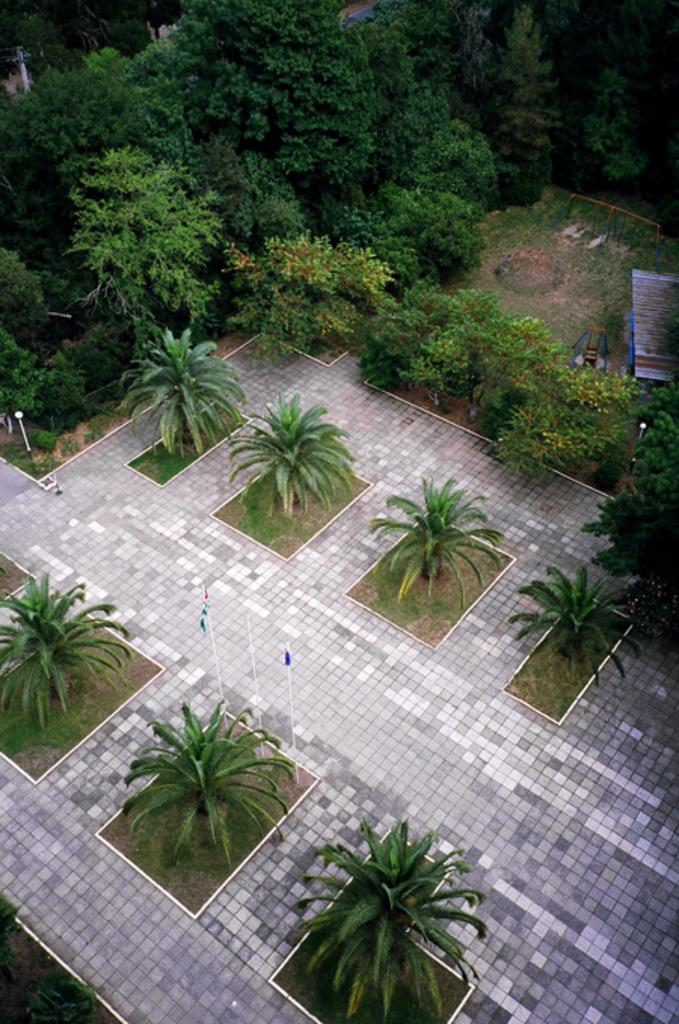What type of surface is visible in the image? There is flooring in the image. What natural elements can be seen in the image? There are trees in the image. What man-made objects are present in the image? There are flags in the image. Where is the bench located in the image? The bench is on the right side of the image. Reasoning: Let' background elements, such as the trees, and the man-made objects, like the flags. We also mention the bench and its location to provide a sense of the overall setting. Each question is designed to elicit a specific detail about the image that is known from the provided facts. Absurd Question/Answer: What type of fish can be seen swimming near the queen in the image? There is no queen or fish present in the image. What type of fish can be seen swimming near the queen in the image? There is no queen or fish present in the image. 